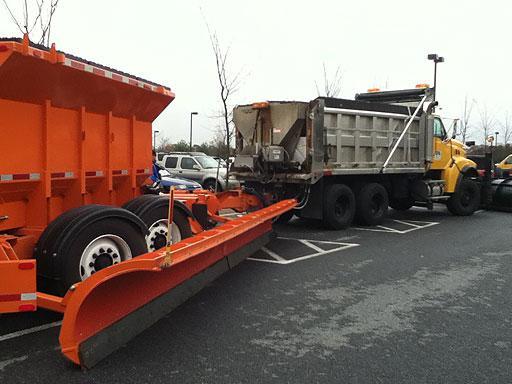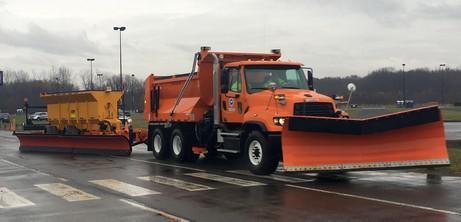The first image is the image on the left, the second image is the image on the right. Assess this claim about the two images: "There are snow scrapers attached to the right hand side of the truck pointing right with no snow on the ground.". Correct or not? Answer yes or no. Yes. The first image is the image on the left, the second image is the image on the right. For the images displayed, is the sentence "In one image the truck towing a second blade and salt bin has a yellow cab and gray body." factually correct? Answer yes or no. Yes. 